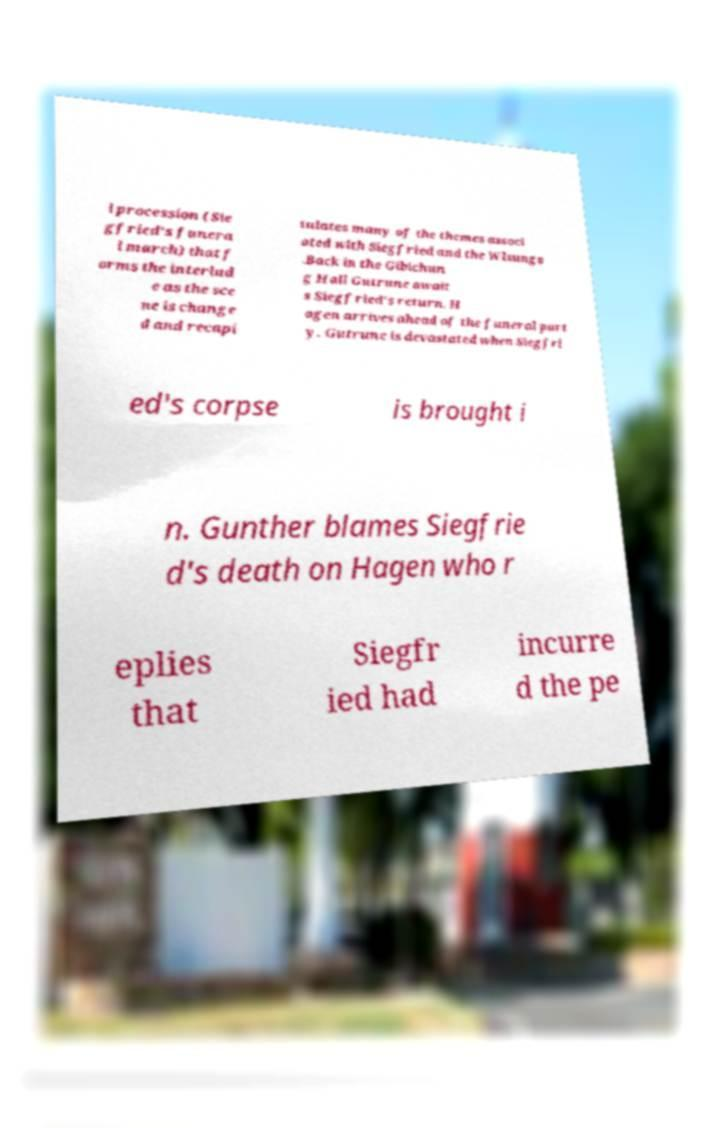Please read and relay the text visible in this image. What does it say? l procession (Sie gfried's funera l march) that f orms the interlud e as the sce ne is change d and recapi tulates many of the themes associ ated with Siegfried and the Wlsungs .Back in the Gibichun g Hall Gutrune await s Siegfried's return. H agen arrives ahead of the funeral part y. Gutrune is devastated when Siegfri ed's corpse is brought i n. Gunther blames Siegfrie d's death on Hagen who r eplies that Siegfr ied had incurre d the pe 